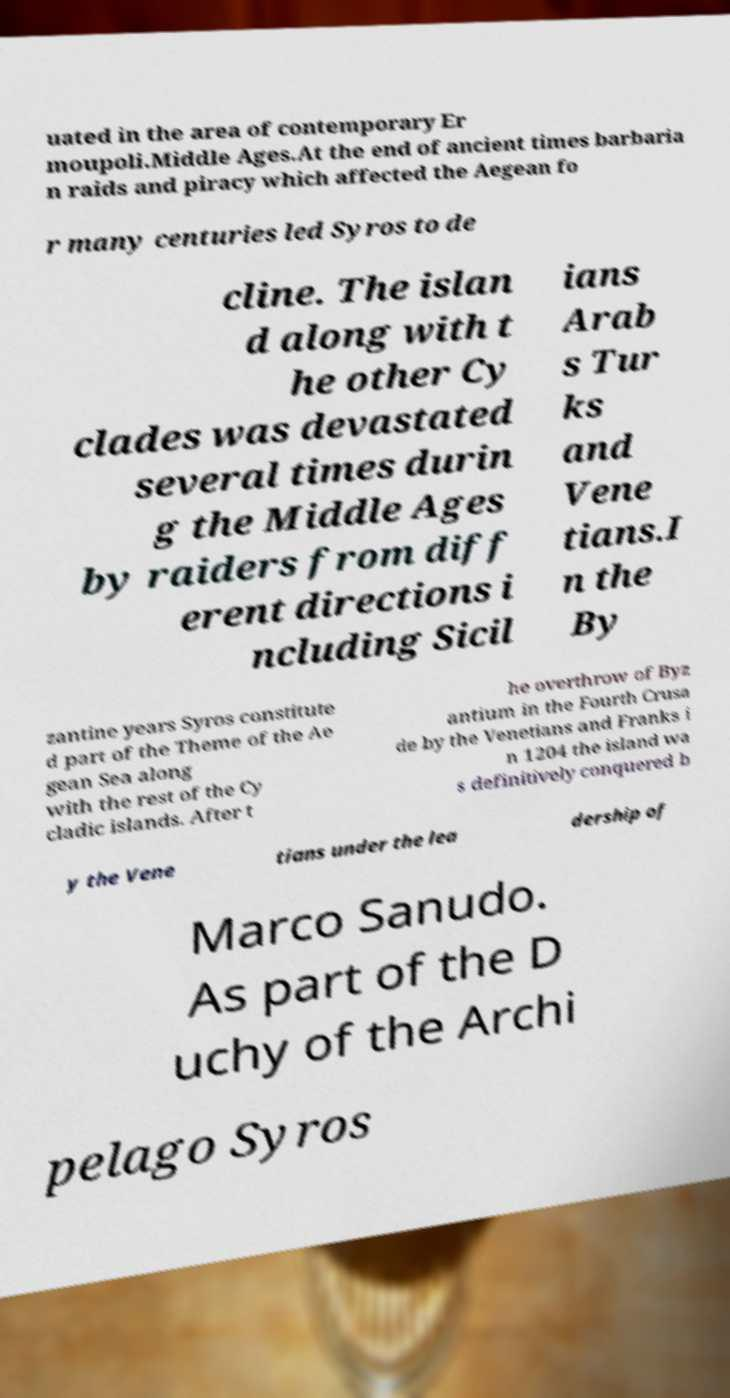Can you accurately transcribe the text from the provided image for me? uated in the area of contemporary Er moupoli.Middle Ages.At the end of ancient times barbaria n raids and piracy which affected the Aegean fo r many centuries led Syros to de cline. The islan d along with t he other Cy clades was devastated several times durin g the Middle Ages by raiders from diff erent directions i ncluding Sicil ians Arab s Tur ks and Vene tians.I n the By zantine years Syros constitute d part of the Theme of the Ae gean Sea along with the rest of the Cy cladic islands. After t he overthrow of Byz antium in the Fourth Crusa de by the Venetians and Franks i n 1204 the island wa s definitively conquered b y the Vene tians under the lea dership of Marco Sanudo. As part of the D uchy of the Archi pelago Syros 